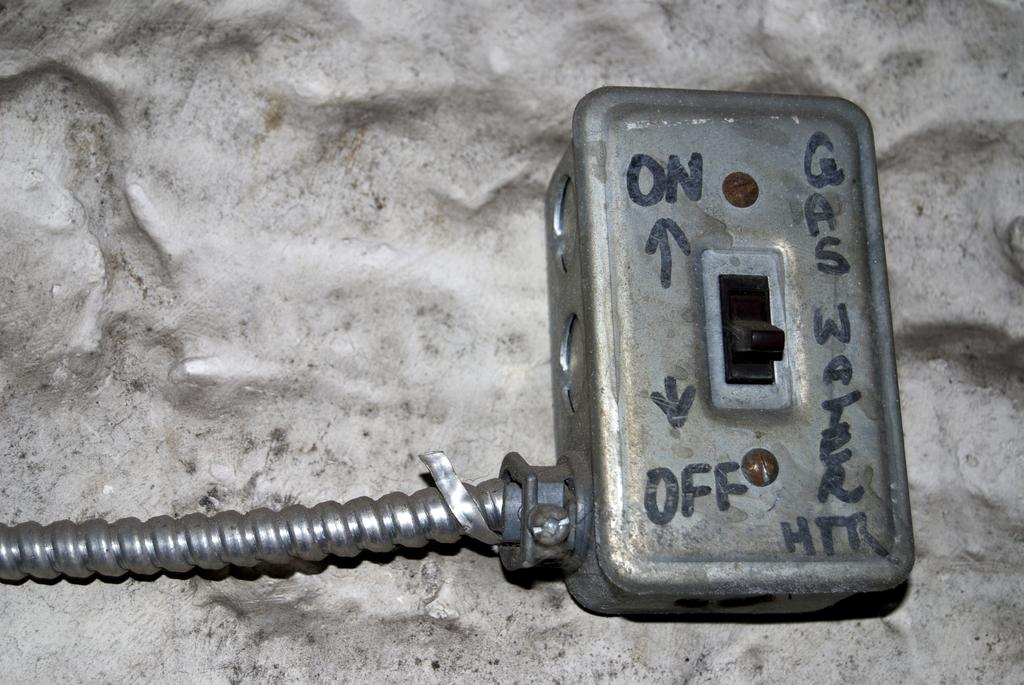<image>
Write a terse but informative summary of the picture. a light switch that has an on and an off 